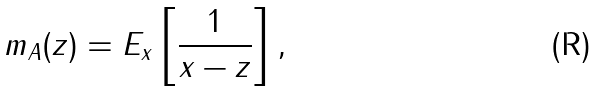Convert formula to latex. <formula><loc_0><loc_0><loc_500><loc_500>m _ { A } ( z ) = E _ { x } \left [ \frac { 1 } { x - z } \right ] ,</formula> 